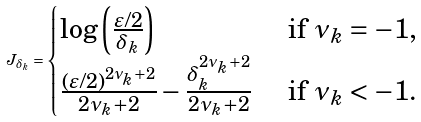Convert formula to latex. <formula><loc_0><loc_0><loc_500><loc_500>J _ { \delta _ { k } } = \begin{cases} \log \left ( \frac { \varepsilon / 2 } { \delta _ { k } } \right ) & \text { if } \nu _ { k } = - 1 , \\ \frac { ( \varepsilon / 2 ) ^ { 2 \nu _ { k } + 2 } } { 2 \nu _ { k } + 2 } - \frac { \delta _ { k } ^ { 2 \nu _ { k } + 2 } } { 2 \nu _ { k } + 2 } & \text { if } \nu _ { k } < - 1 . \end{cases}</formula> 